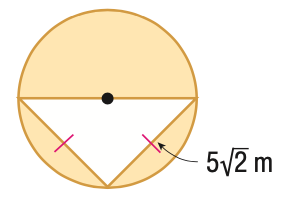Answer the mathemtical geometry problem and directly provide the correct option letter.
Question: Find the area of the shaded region. Round to the nearest tenth.
Choices: A: 25.0 B: 53.5 C: 78.5 D: 103.5 B 